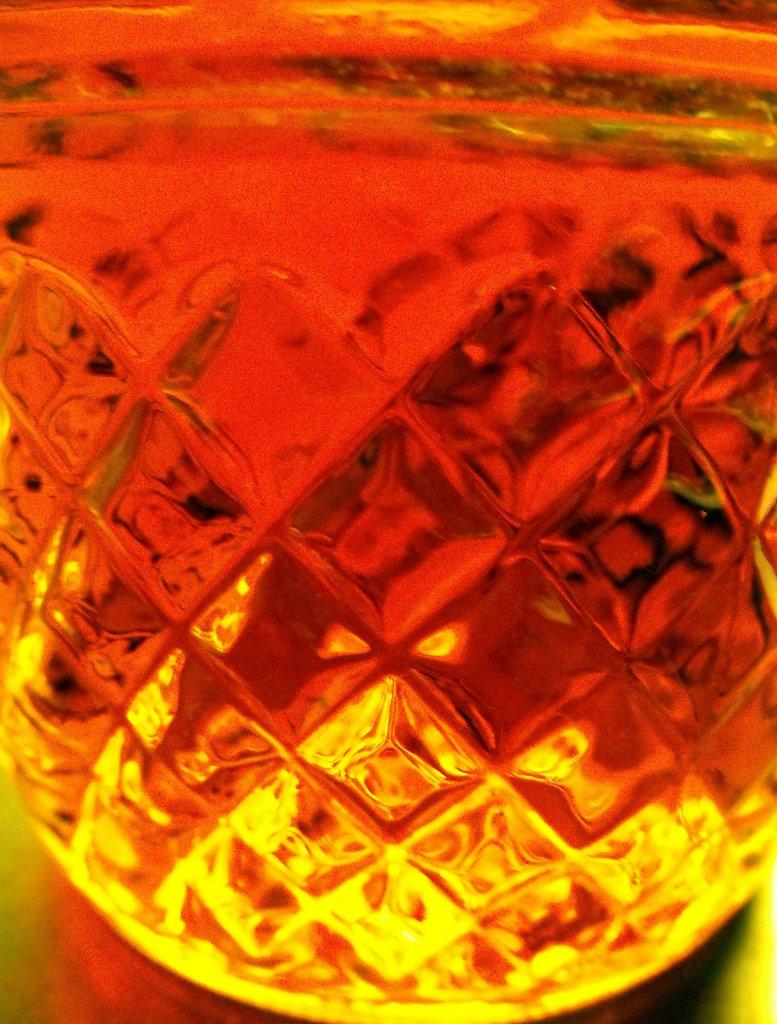What type of material is featured in the image? There is colorful glass in the image. What type of goose can be seen arguing with the manager in the image? There is no goose or manager present in the image; it only features colorful glass. 